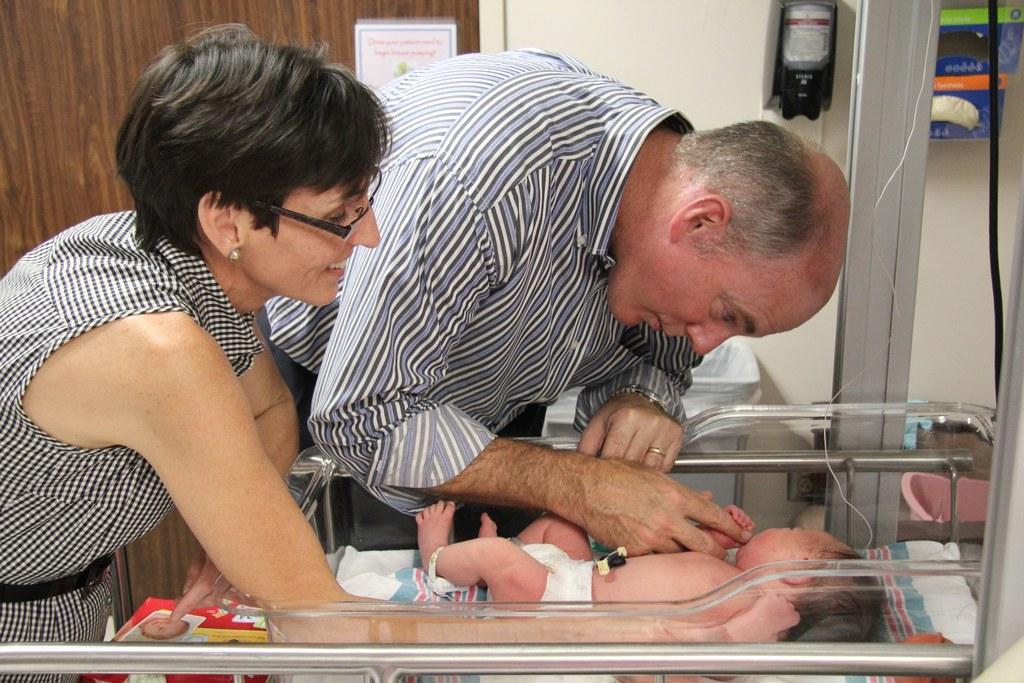Describe this image in one or two sentences. In this image I can see two people are holding the baby. I can see the baby is lying on the white color cloth. I can see few objects, wall and the board is attached to the brown color surface. 